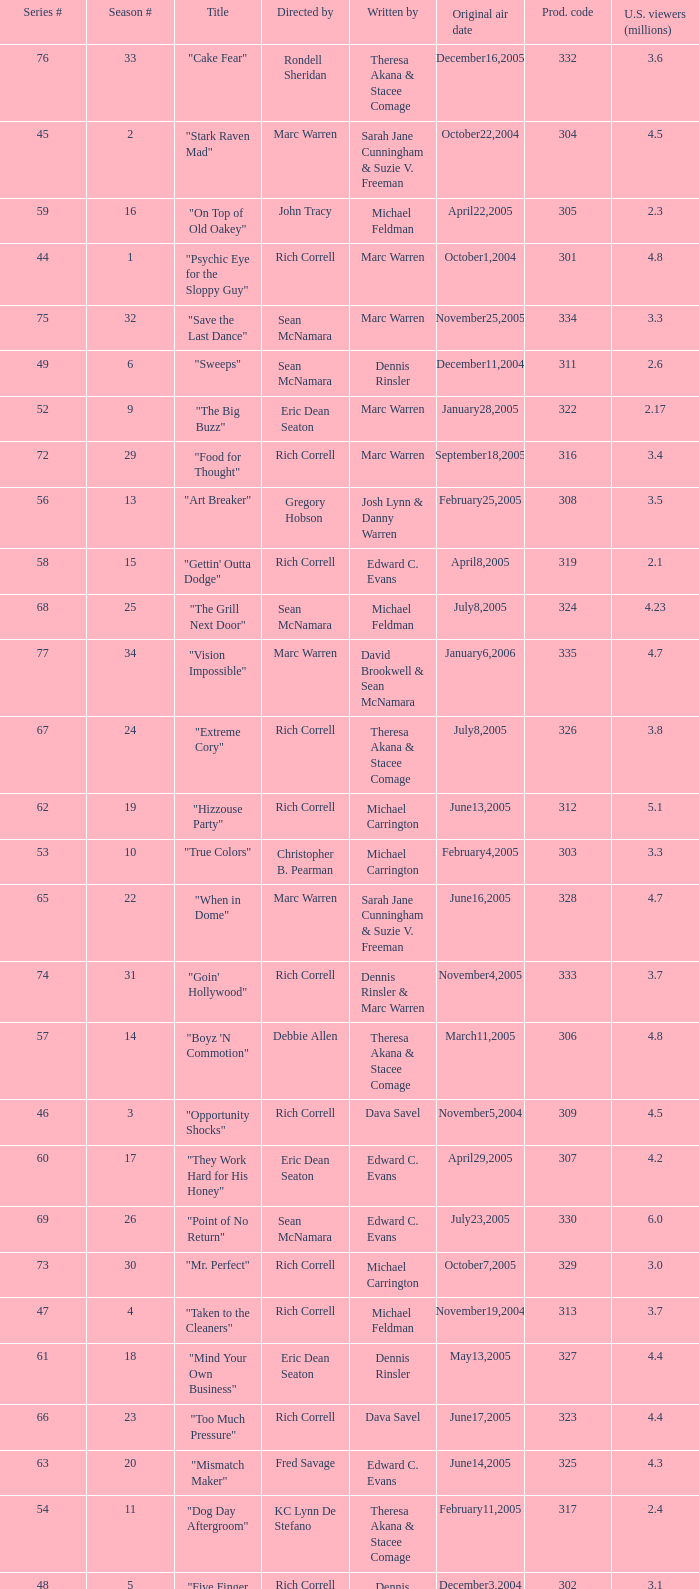What is the title of the episode directed by Rich Correll and written by Dennis Rinsler? "Five Finger Discount". Would you be able to parse every entry in this table? {'header': ['Series #', 'Season #', 'Title', 'Directed by', 'Written by', 'Original air date', 'Prod. code', 'U.S. viewers (millions)'], 'rows': [['76', '33', '"Cake Fear"', 'Rondell Sheridan', 'Theresa Akana & Stacee Comage', 'December16,2005', '332', '3.6'], ['45', '2', '"Stark Raven Mad"', 'Marc Warren', 'Sarah Jane Cunningham & Suzie V. Freeman', 'October22,2004', '304', '4.5'], ['59', '16', '"On Top of Old Oakey"', 'John Tracy', 'Michael Feldman', 'April22,2005', '305', '2.3'], ['44', '1', '"Psychic Eye for the Sloppy Guy"', 'Rich Correll', 'Marc Warren', 'October1,2004', '301', '4.8'], ['75', '32', '"Save the Last Dance"', 'Sean McNamara', 'Marc Warren', 'November25,2005', '334', '3.3'], ['49', '6', '"Sweeps"', 'Sean McNamara', 'Dennis Rinsler', 'December11,2004', '311', '2.6'], ['52', '9', '"The Big Buzz"', 'Eric Dean Seaton', 'Marc Warren', 'January28,2005', '322', '2.17'], ['72', '29', '"Food for Thought"', 'Rich Correll', 'Marc Warren', 'September18,2005', '316', '3.4'], ['56', '13', '"Art Breaker"', 'Gregory Hobson', 'Josh Lynn & Danny Warren', 'February25,2005', '308', '3.5'], ['58', '15', '"Gettin\' Outta Dodge"', 'Rich Correll', 'Edward C. Evans', 'April8,2005', '319', '2.1'], ['68', '25', '"The Grill Next Door"', 'Sean McNamara', 'Michael Feldman', 'July8,2005', '324', '4.23'], ['77', '34', '"Vision Impossible"', 'Marc Warren', 'David Brookwell & Sean McNamara', 'January6,2006', '335', '4.7'], ['67', '24', '"Extreme Cory"', 'Rich Correll', 'Theresa Akana & Stacee Comage', 'July8,2005', '326', '3.8'], ['62', '19', '"Hizzouse Party"', 'Rich Correll', 'Michael Carrington', 'June13,2005', '312', '5.1'], ['53', '10', '"True Colors"', 'Christopher B. Pearman', 'Michael Carrington', 'February4,2005', '303', '3.3'], ['65', '22', '"When in Dome"', 'Marc Warren', 'Sarah Jane Cunningham & Suzie V. Freeman', 'June16,2005', '328', '4.7'], ['74', '31', '"Goin\' Hollywood"', 'Rich Correll', 'Dennis Rinsler & Marc Warren', 'November4,2005', '333', '3.7'], ['57', '14', '"Boyz \'N Commotion"', 'Debbie Allen', 'Theresa Akana & Stacee Comage', 'March11,2005', '306', '4.8'], ['46', '3', '"Opportunity Shocks"', 'Rich Correll', 'Dava Savel', 'November5,2004', '309', '4.5'], ['60', '17', '"They Work Hard for His Honey"', 'Eric Dean Seaton', 'Edward C. Evans', 'April29,2005', '307', '4.2'], ['69', '26', '"Point of No Return"', 'Sean McNamara', 'Edward C. Evans', 'July23,2005', '330', '6.0'], ['73', '30', '"Mr. Perfect"', 'Rich Correll', 'Michael Carrington', 'October7,2005', '329', '3.0'], ['47', '4', '"Taken to the Cleaners"', 'Rich Correll', 'Michael Feldman', 'November19,2004', '313', '3.7'], ['61', '18', '"Mind Your Own Business"', 'Eric Dean Seaton', 'Dennis Rinsler', 'May13,2005', '327', '4.4'], ['66', '23', '"Too Much Pressure"', 'Rich Correll', 'Dava Savel', 'June17,2005', '323', '4.4'], ['63', '20', '"Mismatch Maker"', 'Fred Savage', 'Edward C. Evans', 'June14,2005', '325', '4.3'], ['54', '11', '"Dog Day Aftergroom"', 'KC Lynn De Stefano', 'Theresa Akana & Stacee Comage', 'February11,2005', '317', '2.4'], ['48', '5', '"Five Finger Discount"', 'Rich Correll', 'Dennis Rinsler', 'December3,2004', '302', '3.1'], ['51', '8', '"Bend It Like Baxter"', 'Rich Correll', 'Dava Savel', 'January7,2005', '315', '4.0'], ['50', '7', '"Double Vision"', "T'Keyah Crystal Keymáh", 'Sarah Jane Cunningham & Suzie V. Freeman', 'December17,2004', '318', '5.5'], ['55', '12', '"Royal Treatment"', 'Christopher B. Pearman', 'Sarah Jane Cunningham & Suzie V. Freeman', 'February18,2005', '310', '2.7']]} 